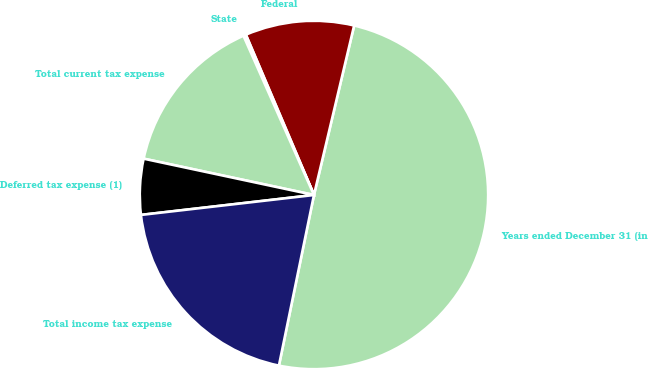Convert chart to OTSL. <chart><loc_0><loc_0><loc_500><loc_500><pie_chart><fcel>Years ended December 31 (in<fcel>Federal<fcel>State<fcel>Total current tax expense<fcel>Deferred tax expense (1)<fcel>Total income tax expense<nl><fcel>49.52%<fcel>10.1%<fcel>0.24%<fcel>15.02%<fcel>5.17%<fcel>19.95%<nl></chart> 